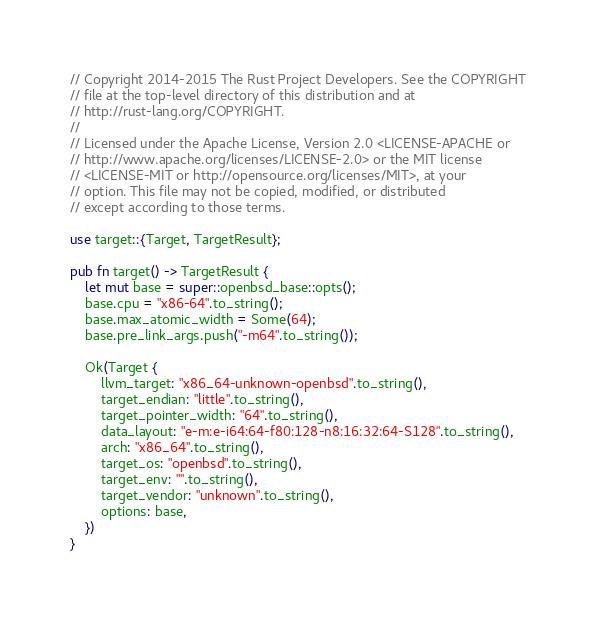Convert code to text. <code><loc_0><loc_0><loc_500><loc_500><_Rust_>// Copyright 2014-2015 The Rust Project Developers. See the COPYRIGHT
// file at the top-level directory of this distribution and at
// http://rust-lang.org/COPYRIGHT.
//
// Licensed under the Apache License, Version 2.0 <LICENSE-APACHE or
// http://www.apache.org/licenses/LICENSE-2.0> or the MIT license
// <LICENSE-MIT or http://opensource.org/licenses/MIT>, at your
// option. This file may not be copied, modified, or distributed
// except according to those terms.

use target::{Target, TargetResult};

pub fn target() -> TargetResult {
    let mut base = super::openbsd_base::opts();
    base.cpu = "x86-64".to_string();
    base.max_atomic_width = Some(64);
    base.pre_link_args.push("-m64".to_string());

    Ok(Target {
        llvm_target: "x86_64-unknown-openbsd".to_string(),
        target_endian: "little".to_string(),
        target_pointer_width: "64".to_string(),
        data_layout: "e-m:e-i64:64-f80:128-n8:16:32:64-S128".to_string(),
        arch: "x86_64".to_string(),
        target_os: "openbsd".to_string(),
        target_env: "".to_string(),
        target_vendor: "unknown".to_string(),
        options: base,
    })
}
</code> 